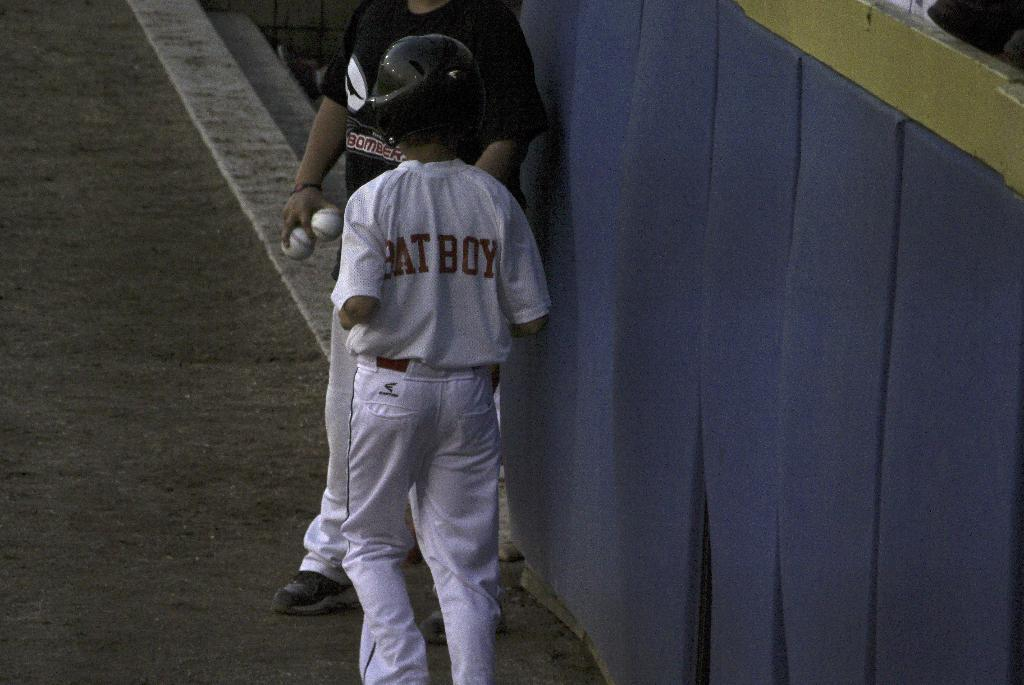Provide a one-sentence caption for the provided image. a person that has bat boy written on their jersey. 